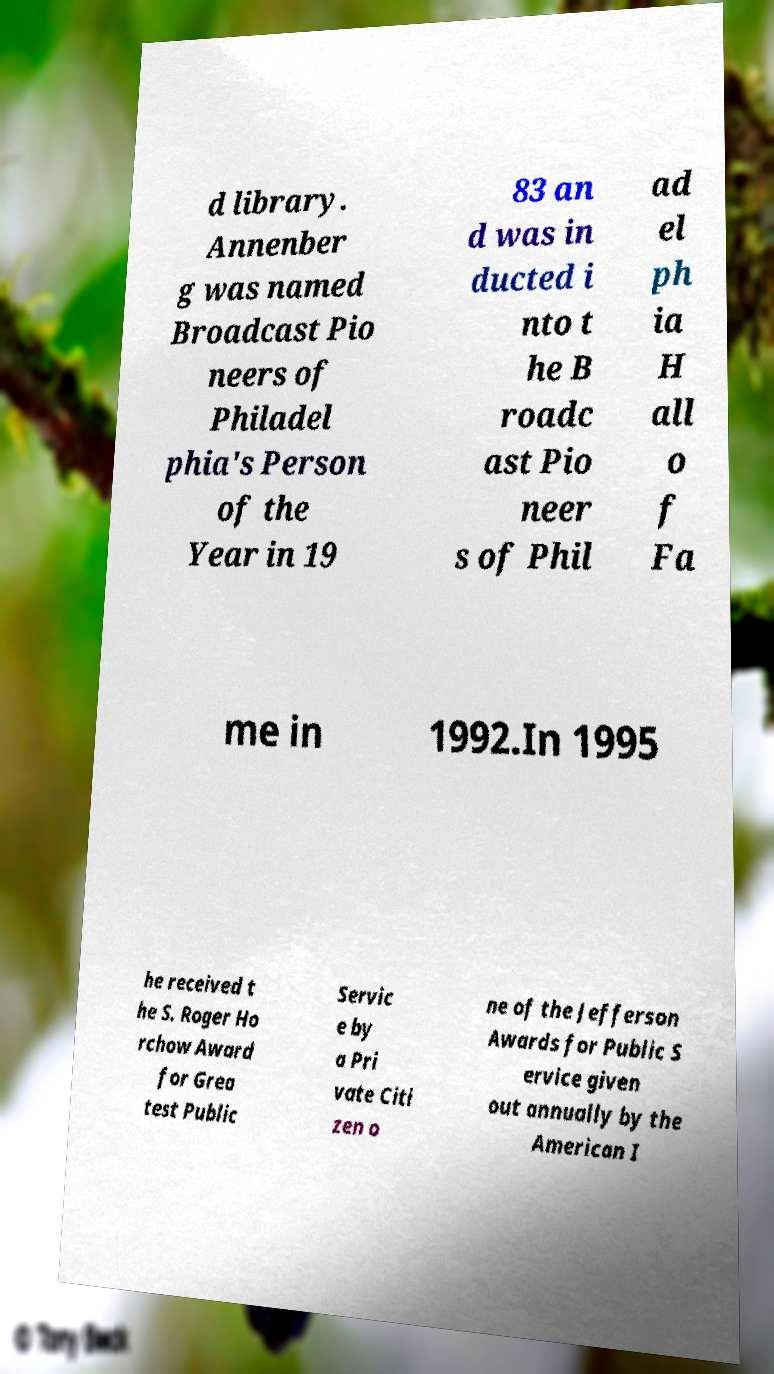Can you read and provide the text displayed in the image?This photo seems to have some interesting text. Can you extract and type it out for me? d library. Annenber g was named Broadcast Pio neers of Philadel phia's Person of the Year in 19 83 an d was in ducted i nto t he B roadc ast Pio neer s of Phil ad el ph ia H all o f Fa me in 1992.In 1995 he received t he S. Roger Ho rchow Award for Grea test Public Servic e by a Pri vate Citi zen o ne of the Jefferson Awards for Public S ervice given out annually by the American I 